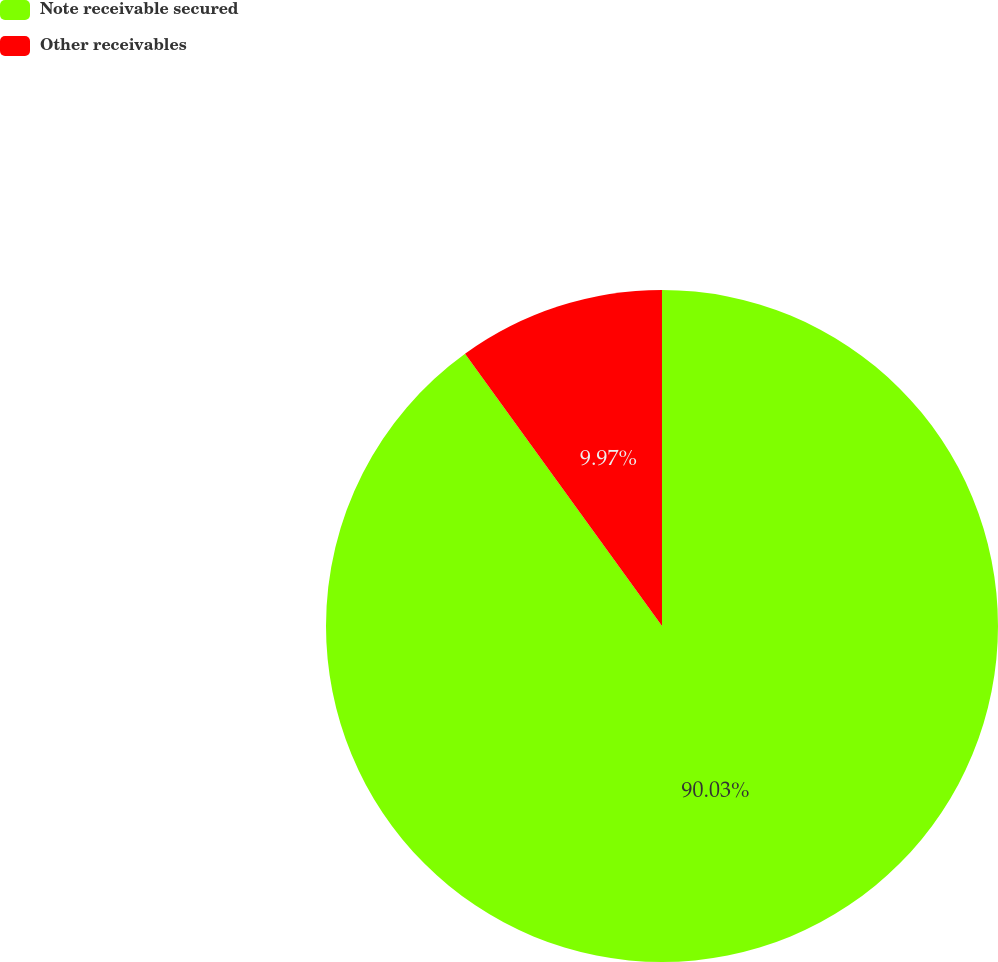Convert chart. <chart><loc_0><loc_0><loc_500><loc_500><pie_chart><fcel>Note receivable secured<fcel>Other receivables<nl><fcel>90.03%<fcel>9.97%<nl></chart> 